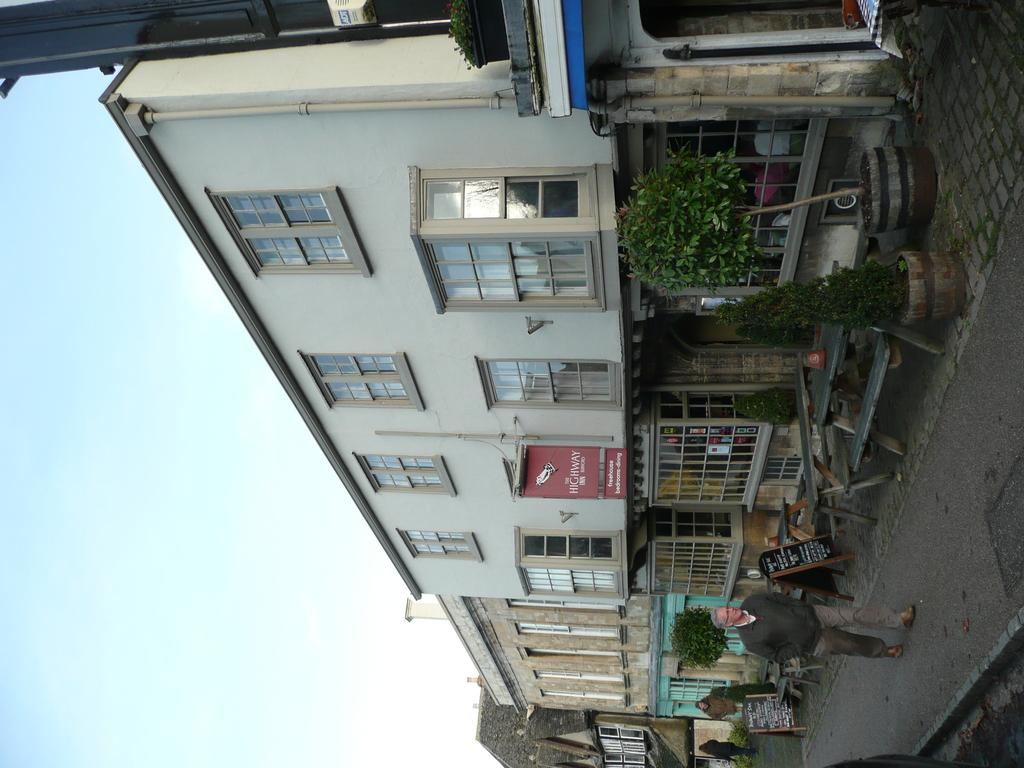What type of structures can be seen in the image? There are buildings in the image. Are there any living beings present in the image? Yes, there are people in the image. What type of objects can be seen near the buildings? There are plant pots and benches in the image. What else can be found on the ground in the image? There are other objects on the ground in the image. What is visible in the background of the image? The sky is visible in the background of the image. Can you tell me how many people are swimming in the image? There is no swimming activity depicted in the image. What type of heat source can be seen in the image? There is no heat source visible in the image. 